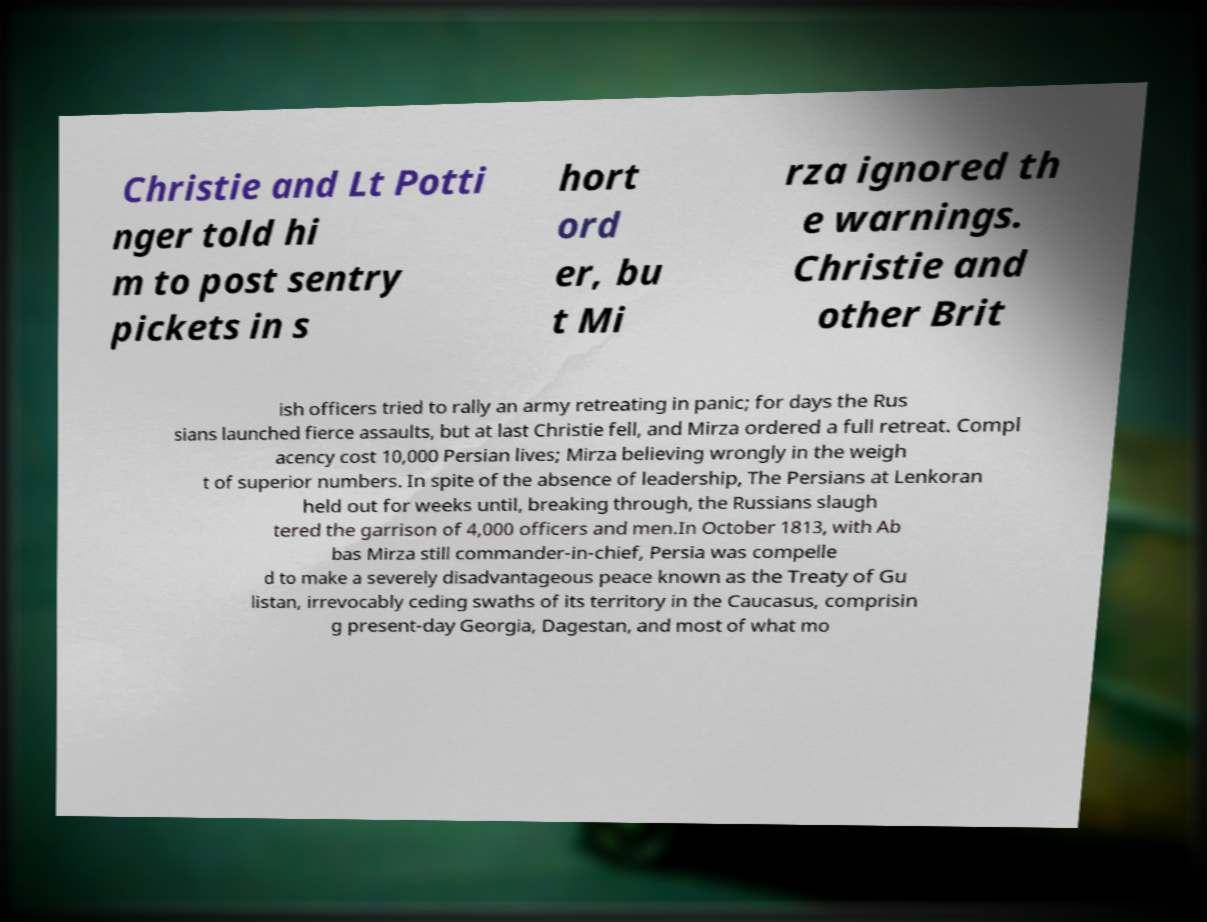Can you accurately transcribe the text from the provided image for me? Christie and Lt Potti nger told hi m to post sentry pickets in s hort ord er, bu t Mi rza ignored th e warnings. Christie and other Brit ish officers tried to rally an army retreating in panic; for days the Rus sians launched fierce assaults, but at last Christie fell, and Mirza ordered a full retreat. Compl acency cost 10,000 Persian lives; Mirza believing wrongly in the weigh t of superior numbers. In spite of the absence of leadership, The Persians at Lenkoran held out for weeks until, breaking through, the Russians slaugh tered the garrison of 4,000 officers and men.In October 1813, with Ab bas Mirza still commander-in-chief, Persia was compelle d to make a severely disadvantageous peace known as the Treaty of Gu listan, irrevocably ceding swaths of its territory in the Caucasus, comprisin g present-day Georgia, Dagestan, and most of what mo 